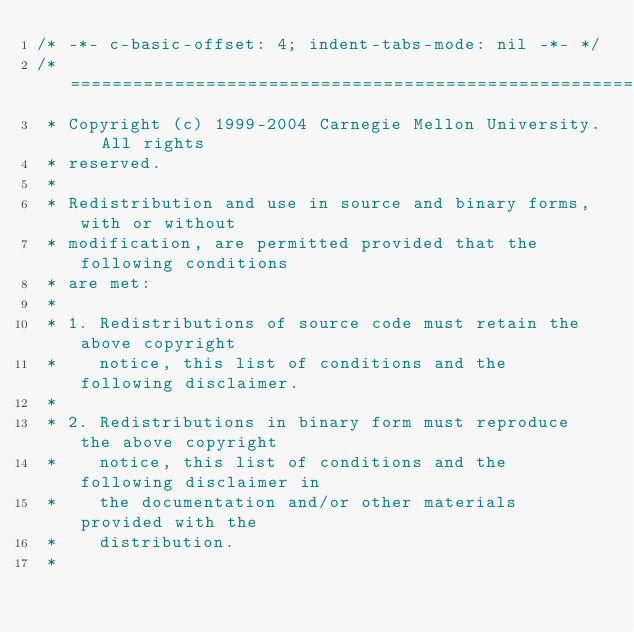<code> <loc_0><loc_0><loc_500><loc_500><_C_>/* -*- c-basic-offset: 4; indent-tabs-mode: nil -*- */
/* ====================================================================
 * Copyright (c) 1999-2004 Carnegie Mellon University.  All rights
 * reserved.
 *
 * Redistribution and use in source and binary forms, with or without
 * modification, are permitted provided that the following conditions
 * are met:
 *
 * 1. Redistributions of source code must retain the above copyright
 *    notice, this list of conditions and the following disclaimer. 
 *
 * 2. Redistributions in binary form must reproduce the above copyright
 *    notice, this list of conditions and the following disclaimer in
 *    the documentation and/or other materials provided with the
 *    distribution.
 *</code> 